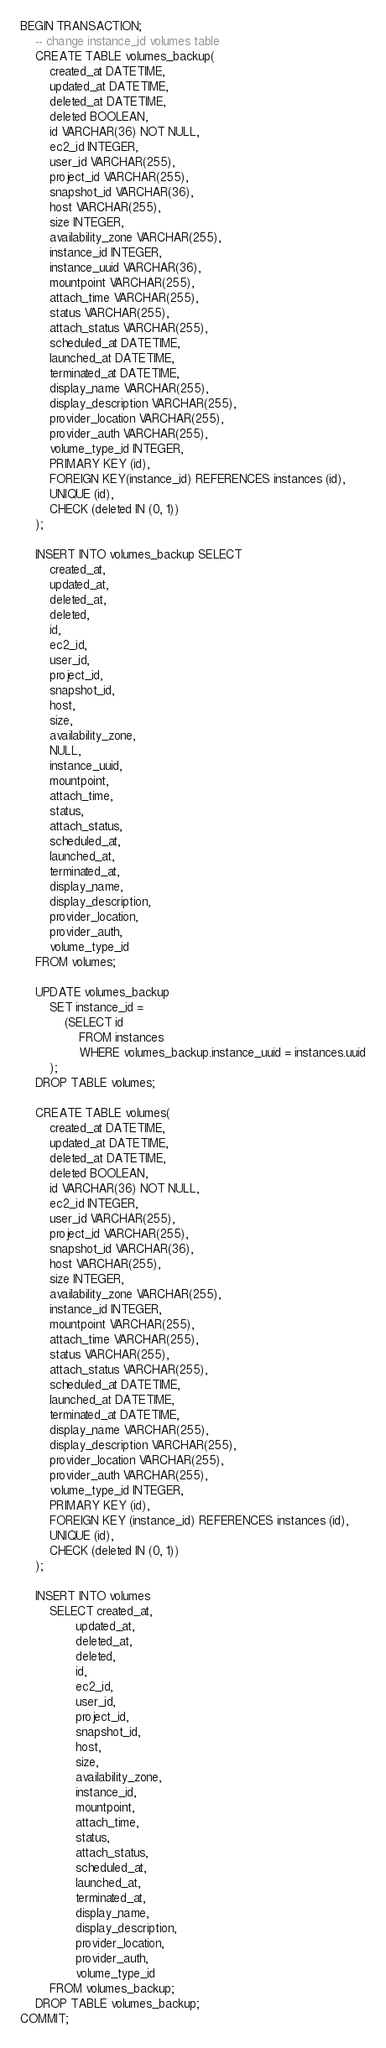<code> <loc_0><loc_0><loc_500><loc_500><_SQL_>BEGIN TRANSACTION;
    -- change instance_id volumes table
    CREATE TABLE volumes_backup(
        created_at DATETIME,
        updated_at DATETIME,
        deleted_at DATETIME,
        deleted BOOLEAN,
        id VARCHAR(36) NOT NULL,
        ec2_id INTEGER,
        user_id VARCHAR(255),
        project_id VARCHAR(255),
        snapshot_id VARCHAR(36),
        host VARCHAR(255),
        size INTEGER,
        availability_zone VARCHAR(255),
        instance_id INTEGER,
        instance_uuid VARCHAR(36),
        mountpoint VARCHAR(255),
        attach_time VARCHAR(255),
        status VARCHAR(255),
        attach_status VARCHAR(255),
        scheduled_at DATETIME,
        launched_at DATETIME,
        terminated_at DATETIME,
        display_name VARCHAR(255),
        display_description VARCHAR(255),
        provider_location VARCHAR(255),
        provider_auth VARCHAR(255),
        volume_type_id INTEGER,
        PRIMARY KEY (id),
        FOREIGN KEY(instance_id) REFERENCES instances (id),
        UNIQUE (id),
        CHECK (deleted IN (0, 1))
    );

    INSERT INTO volumes_backup SELECT
        created_at,
        updated_at,
        deleted_at,
        deleted,
        id,
        ec2_id,
        user_id,
        project_id,
        snapshot_id,
        host,
        size,
        availability_zone,
        NULL,
        instance_uuid,
        mountpoint,
        attach_time,
        status,
        attach_status,
        scheduled_at,
        launched_at,
        terminated_at,
        display_name,
        display_description,
        provider_location,
        provider_auth,
        volume_type_id
    FROM volumes;

    UPDATE volumes_backup
        SET instance_id =
            (SELECT id
                FROM instances
                WHERE volumes_backup.instance_uuid = instances.uuid
        );
    DROP TABLE volumes;

    CREATE TABLE volumes(
        created_at DATETIME,
        updated_at DATETIME,
        deleted_at DATETIME,
        deleted BOOLEAN,
        id VARCHAR(36) NOT NULL,
        ec2_id INTEGER,
        user_id VARCHAR(255),
        project_id VARCHAR(255),
        snapshot_id VARCHAR(36),
        host VARCHAR(255),
        size INTEGER,
        availability_zone VARCHAR(255),
        instance_id INTEGER,
        mountpoint VARCHAR(255),
        attach_time VARCHAR(255),
        status VARCHAR(255),
        attach_status VARCHAR(255),
        scheduled_at DATETIME,
        launched_at DATETIME,
        terminated_at DATETIME,
        display_name VARCHAR(255),
        display_description VARCHAR(255),
        provider_location VARCHAR(255),
        provider_auth VARCHAR(255),
        volume_type_id INTEGER,
        PRIMARY KEY (id),
        FOREIGN KEY (instance_id) REFERENCES instances (id),
        UNIQUE (id),
        CHECK (deleted IN (0, 1))
    );

    INSERT INTO volumes
        SELECT created_at,
               updated_at,
               deleted_at,
               deleted,
               id,
               ec2_id,
               user_id,
               project_id,
               snapshot_id,
               host,
               size,
               availability_zone,
               instance_id,
               mountpoint,
               attach_time,
               status,
               attach_status,
               scheduled_at,
               launched_at,
               terminated_at,
               display_name,
               display_description,
               provider_location,
               provider_auth,
               volume_type_id
        FROM volumes_backup;
    DROP TABLE volumes_backup;
COMMIT;
</code> 